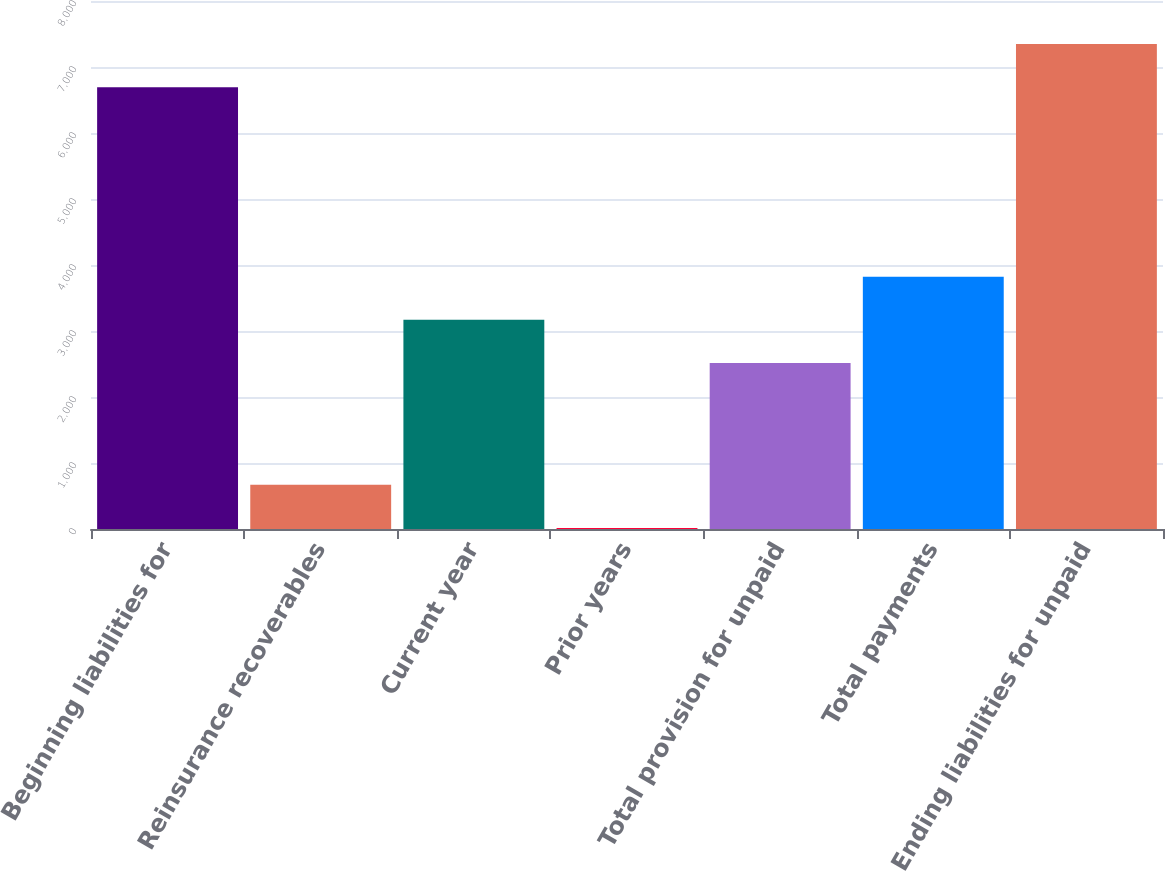<chart> <loc_0><loc_0><loc_500><loc_500><bar_chart><fcel>Beginning liabilities for<fcel>Reinsurance recoverables<fcel>Current year<fcel>Prior years<fcel>Total provision for unpaid<fcel>Total payments<fcel>Ending liabilities for unpaid<nl><fcel>6694<fcel>670<fcel>3170<fcel>17<fcel>2517<fcel>3823<fcel>7347<nl></chart> 